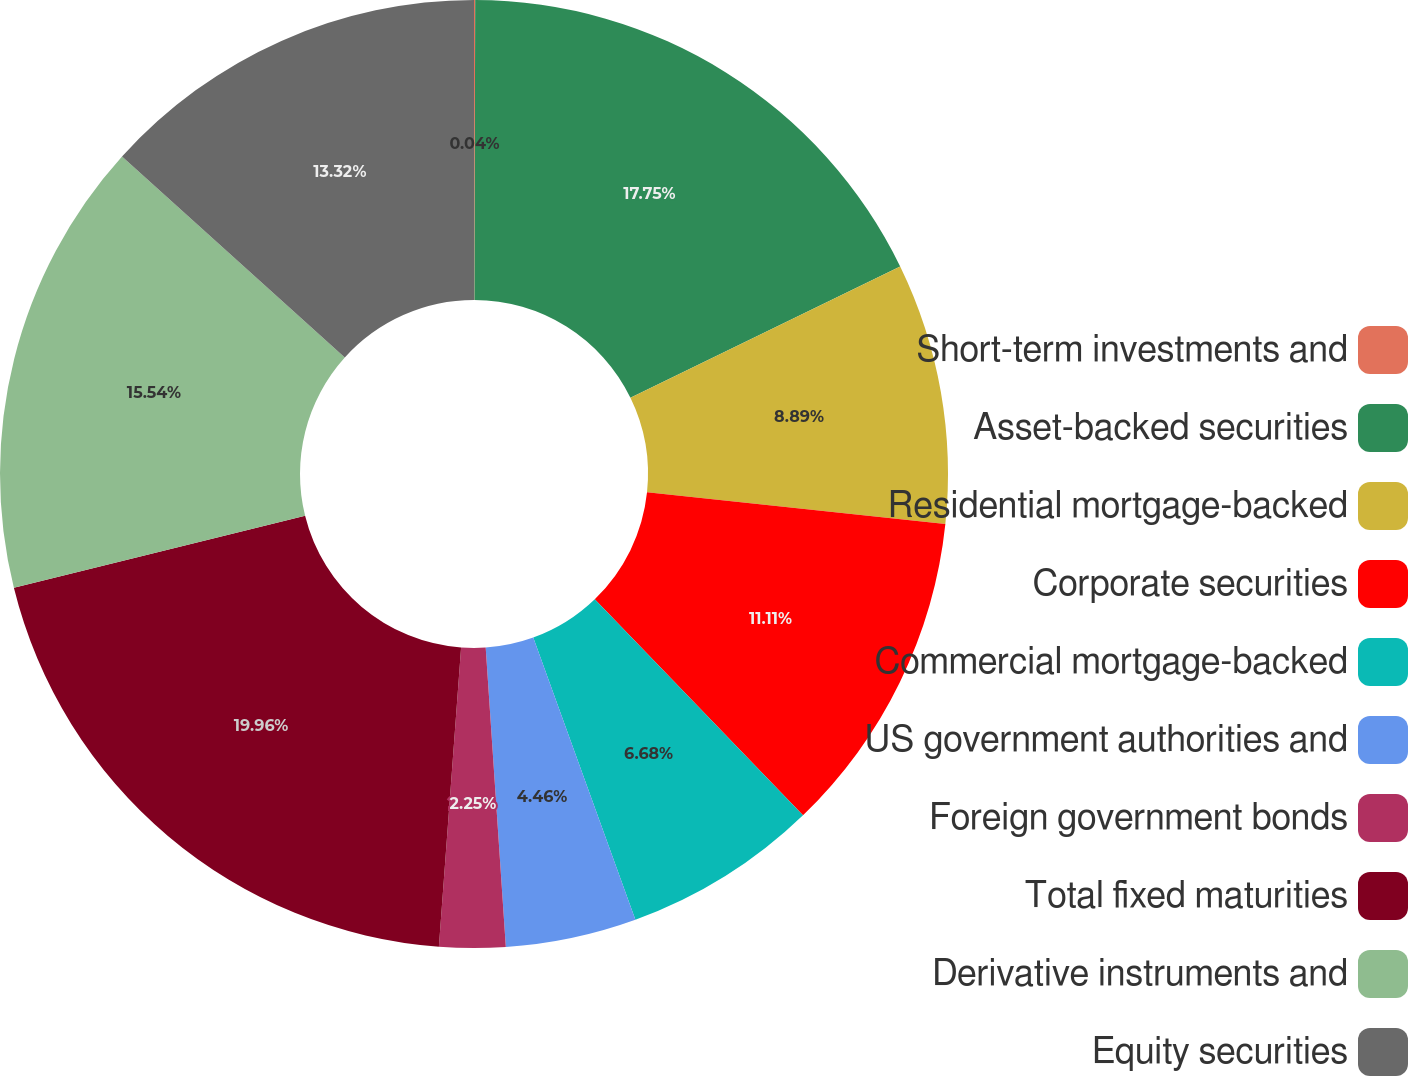<chart> <loc_0><loc_0><loc_500><loc_500><pie_chart><fcel>Short-term investments and<fcel>Asset-backed securities<fcel>Residential mortgage-backed<fcel>Corporate securities<fcel>Commercial mortgage-backed<fcel>US government authorities and<fcel>Foreign government bonds<fcel>Total fixed maturities<fcel>Derivative instruments and<fcel>Equity securities<nl><fcel>0.04%<fcel>17.75%<fcel>8.89%<fcel>11.11%<fcel>6.68%<fcel>4.46%<fcel>2.25%<fcel>19.96%<fcel>15.54%<fcel>13.32%<nl></chart> 